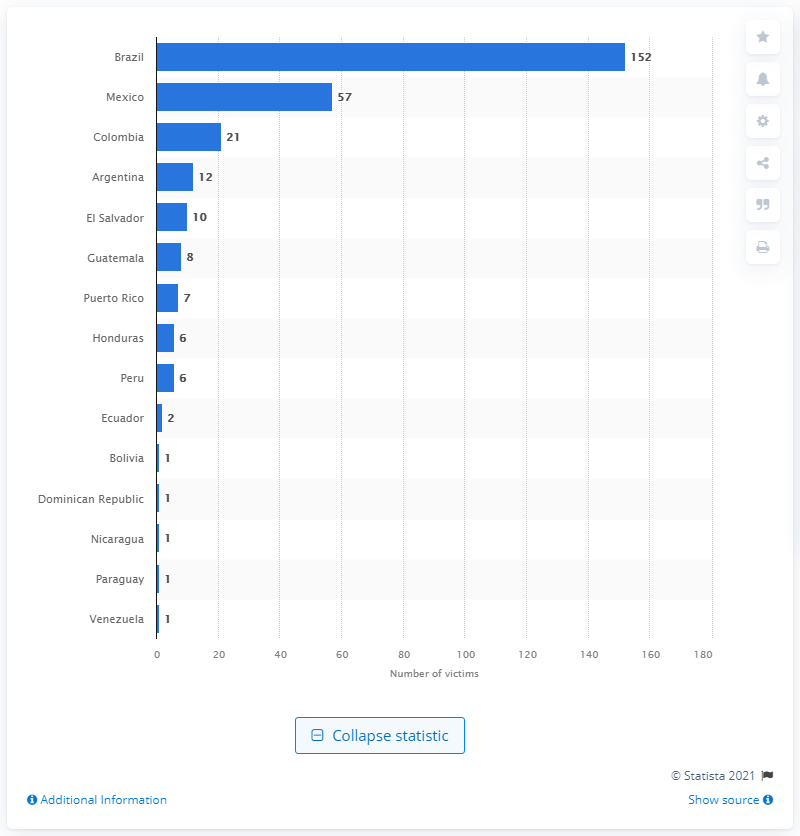List a handful of essential elements in this visual. During the period of October 2019 and September 2020, a total of 152 trans people were killed in Brazil. Mexico was the second deadliest country for trans people in Latin America. 